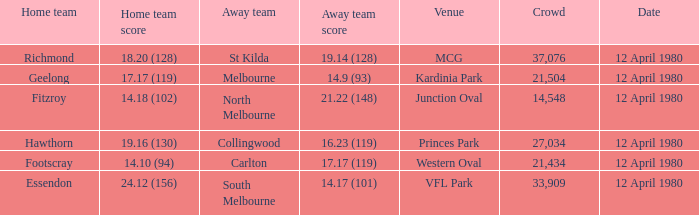Would you be able to parse every entry in this table? {'header': ['Home team', 'Home team score', 'Away team', 'Away team score', 'Venue', 'Crowd', 'Date'], 'rows': [['Richmond', '18.20 (128)', 'St Kilda', '19.14 (128)', 'MCG', '37,076', '12 April 1980'], ['Geelong', '17.17 (119)', 'Melbourne', '14.9 (93)', 'Kardinia Park', '21,504', '12 April 1980'], ['Fitzroy', '14.18 (102)', 'North Melbourne', '21.22 (148)', 'Junction Oval', '14,548', '12 April 1980'], ['Hawthorn', '19.16 (130)', 'Collingwood', '16.23 (119)', 'Princes Park', '27,034', '12 April 1980'], ['Footscray', '14.10 (94)', 'Carlton', '17.17 (119)', 'Western Oval', '21,434', '12 April 1980'], ['Essendon', '24.12 (156)', 'South Melbourne', '14.17 (101)', 'VFL Park', '33,909', '12 April 1980']]} In what venue did essendon have their home games? VFL Park. 